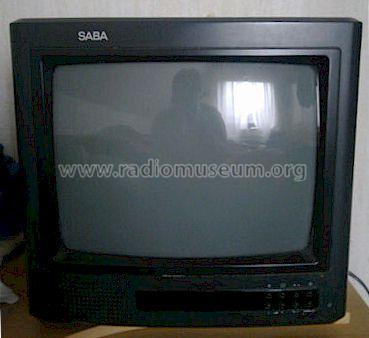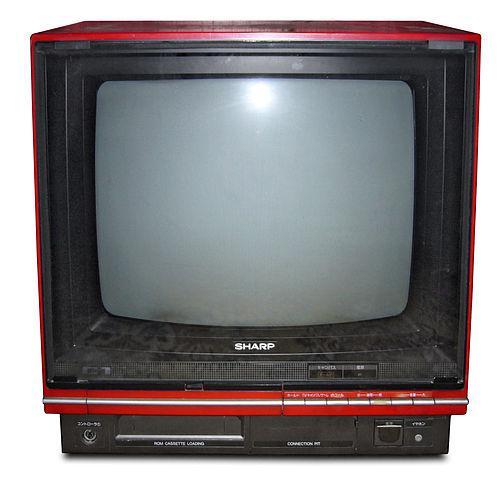The first image is the image on the left, the second image is the image on the right. For the images shown, is this caption "the left pic is of a flat screen monitor" true? Answer yes or no. No. The first image is the image on the left, the second image is the image on the right. Considering the images on both sides, is "The left image has a remote next to a monitor on a wooden surface" valid? Answer yes or no. No. 